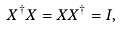<formula> <loc_0><loc_0><loc_500><loc_500>X ^ { \dagger } X = X X ^ { \dagger } = I ,</formula> 